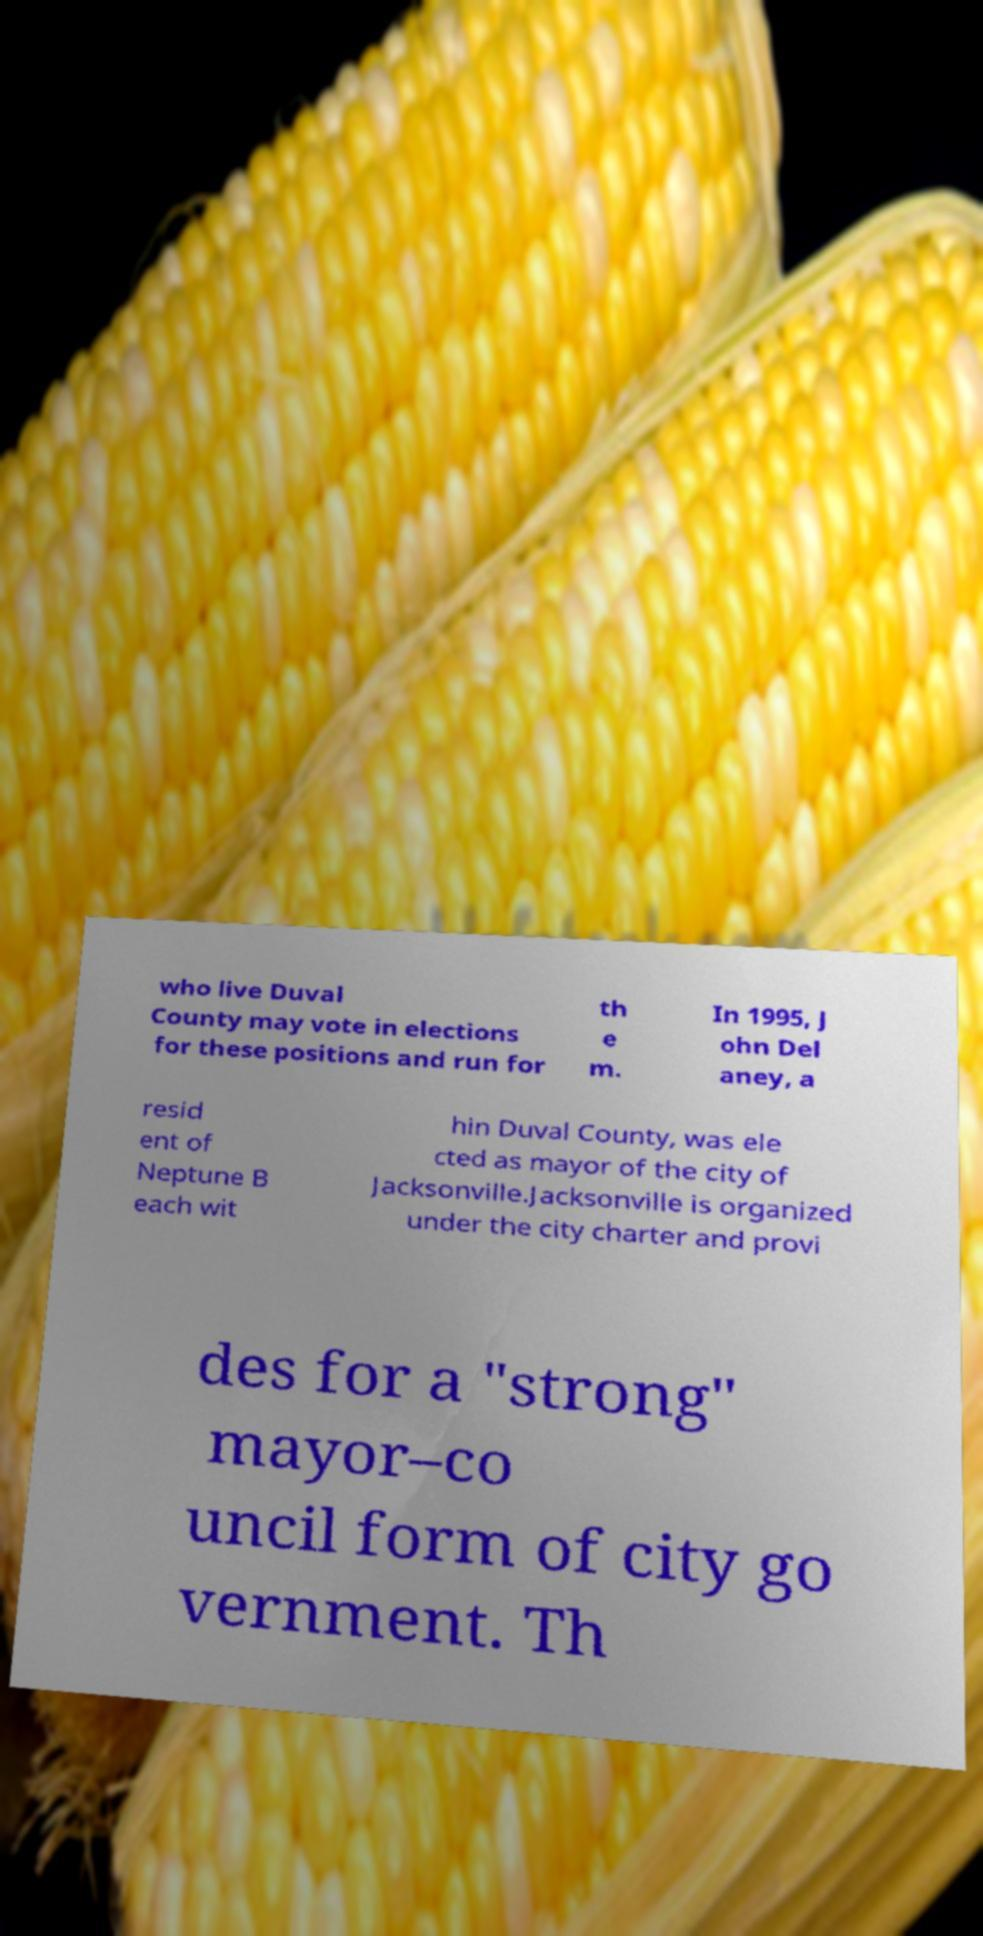Please identify and transcribe the text found in this image. who live Duval County may vote in elections for these positions and run for th e m. In 1995, J ohn Del aney, a resid ent of Neptune B each wit hin Duval County, was ele cted as mayor of the city of Jacksonville.Jacksonville is organized under the city charter and provi des for a "strong" mayor–co uncil form of city go vernment. Th 